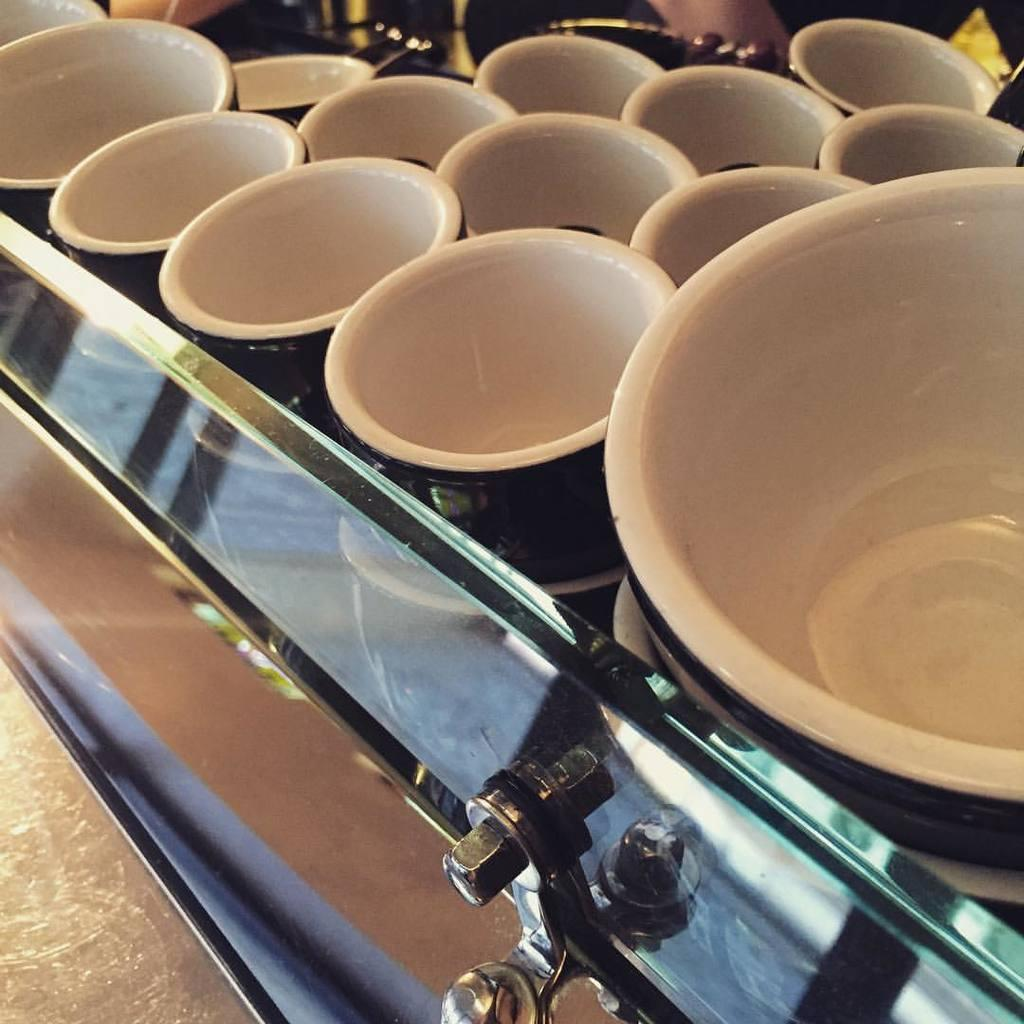What is located in the center of the image? There are bowls in the center of the image. What can be found at the bottom of the image? There is a bolt at the bottom of the image. Can you describe any other objects present in the image? There are additional objects present in the image, but their specific details are not mentioned in the provided facts. How many clover leaves can be seen in the image? There is no mention of clover leaves in the provided facts, so it cannot be determined from the image. What type of whip is being used by the hands in the image? There is no mention of hands or a whip in the provided facts, so it cannot be determined from the image. 